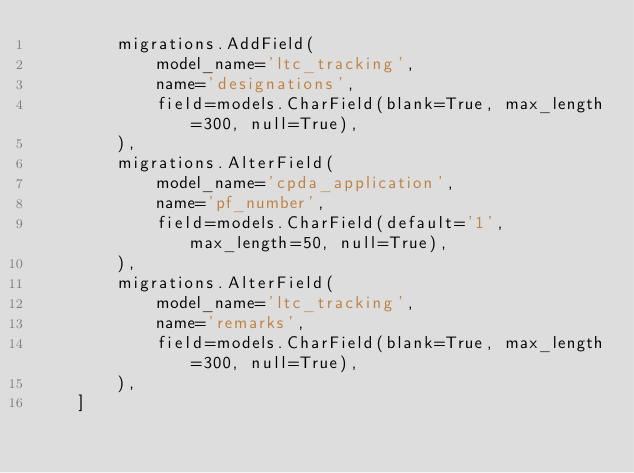<code> <loc_0><loc_0><loc_500><loc_500><_Python_>        migrations.AddField(
            model_name='ltc_tracking',
            name='designations',
            field=models.CharField(blank=True, max_length=300, null=True),
        ),
        migrations.AlterField(
            model_name='cpda_application',
            name='pf_number',
            field=models.CharField(default='1', max_length=50, null=True),
        ),
        migrations.AlterField(
            model_name='ltc_tracking',
            name='remarks',
            field=models.CharField(blank=True, max_length=300, null=True),
        ),
    ]
</code> 